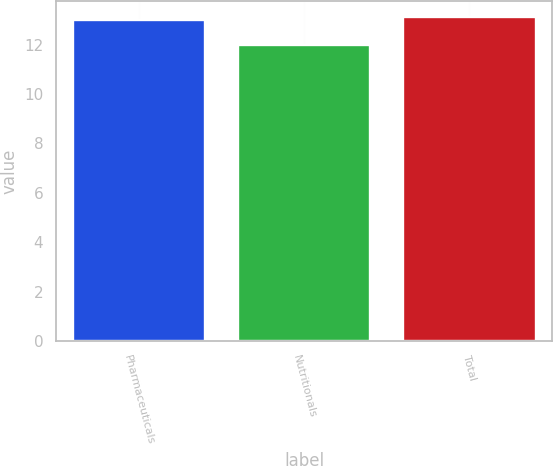Convert chart. <chart><loc_0><loc_0><loc_500><loc_500><bar_chart><fcel>Pharmaceuticals<fcel>Nutritionals<fcel>Total<nl><fcel>13<fcel>12<fcel>13.1<nl></chart> 